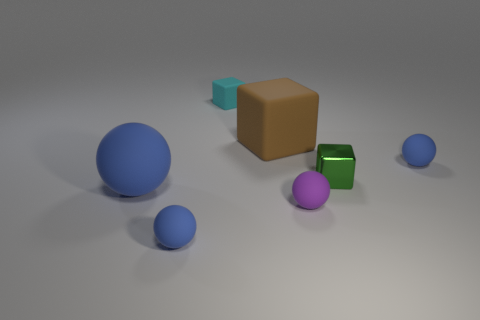What number of things are either big rubber things or small brown metal things?
Give a very brief answer. 2. Does the tiny metallic cube have the same color as the tiny rubber block?
Your answer should be compact. No. Is there anything else that has the same size as the brown rubber object?
Offer a terse response. Yes. There is a small blue rubber thing to the right of the large matte object behind the large blue matte thing; what is its shape?
Make the answer very short. Sphere. Is the number of tiny objects less than the number of blue matte things?
Ensure brevity in your answer.  No. What size is the matte thing that is left of the big brown object and behind the big matte sphere?
Offer a very short reply. Small. Does the purple matte object have the same size as the cyan block?
Your response must be concise. Yes. Is the color of the tiny ball left of the small purple rubber sphere the same as the big sphere?
Keep it short and to the point. Yes. There is a small metal thing; how many cyan things are to the left of it?
Offer a terse response. 1. Are there more large brown things than tiny rubber objects?
Offer a very short reply. No. 